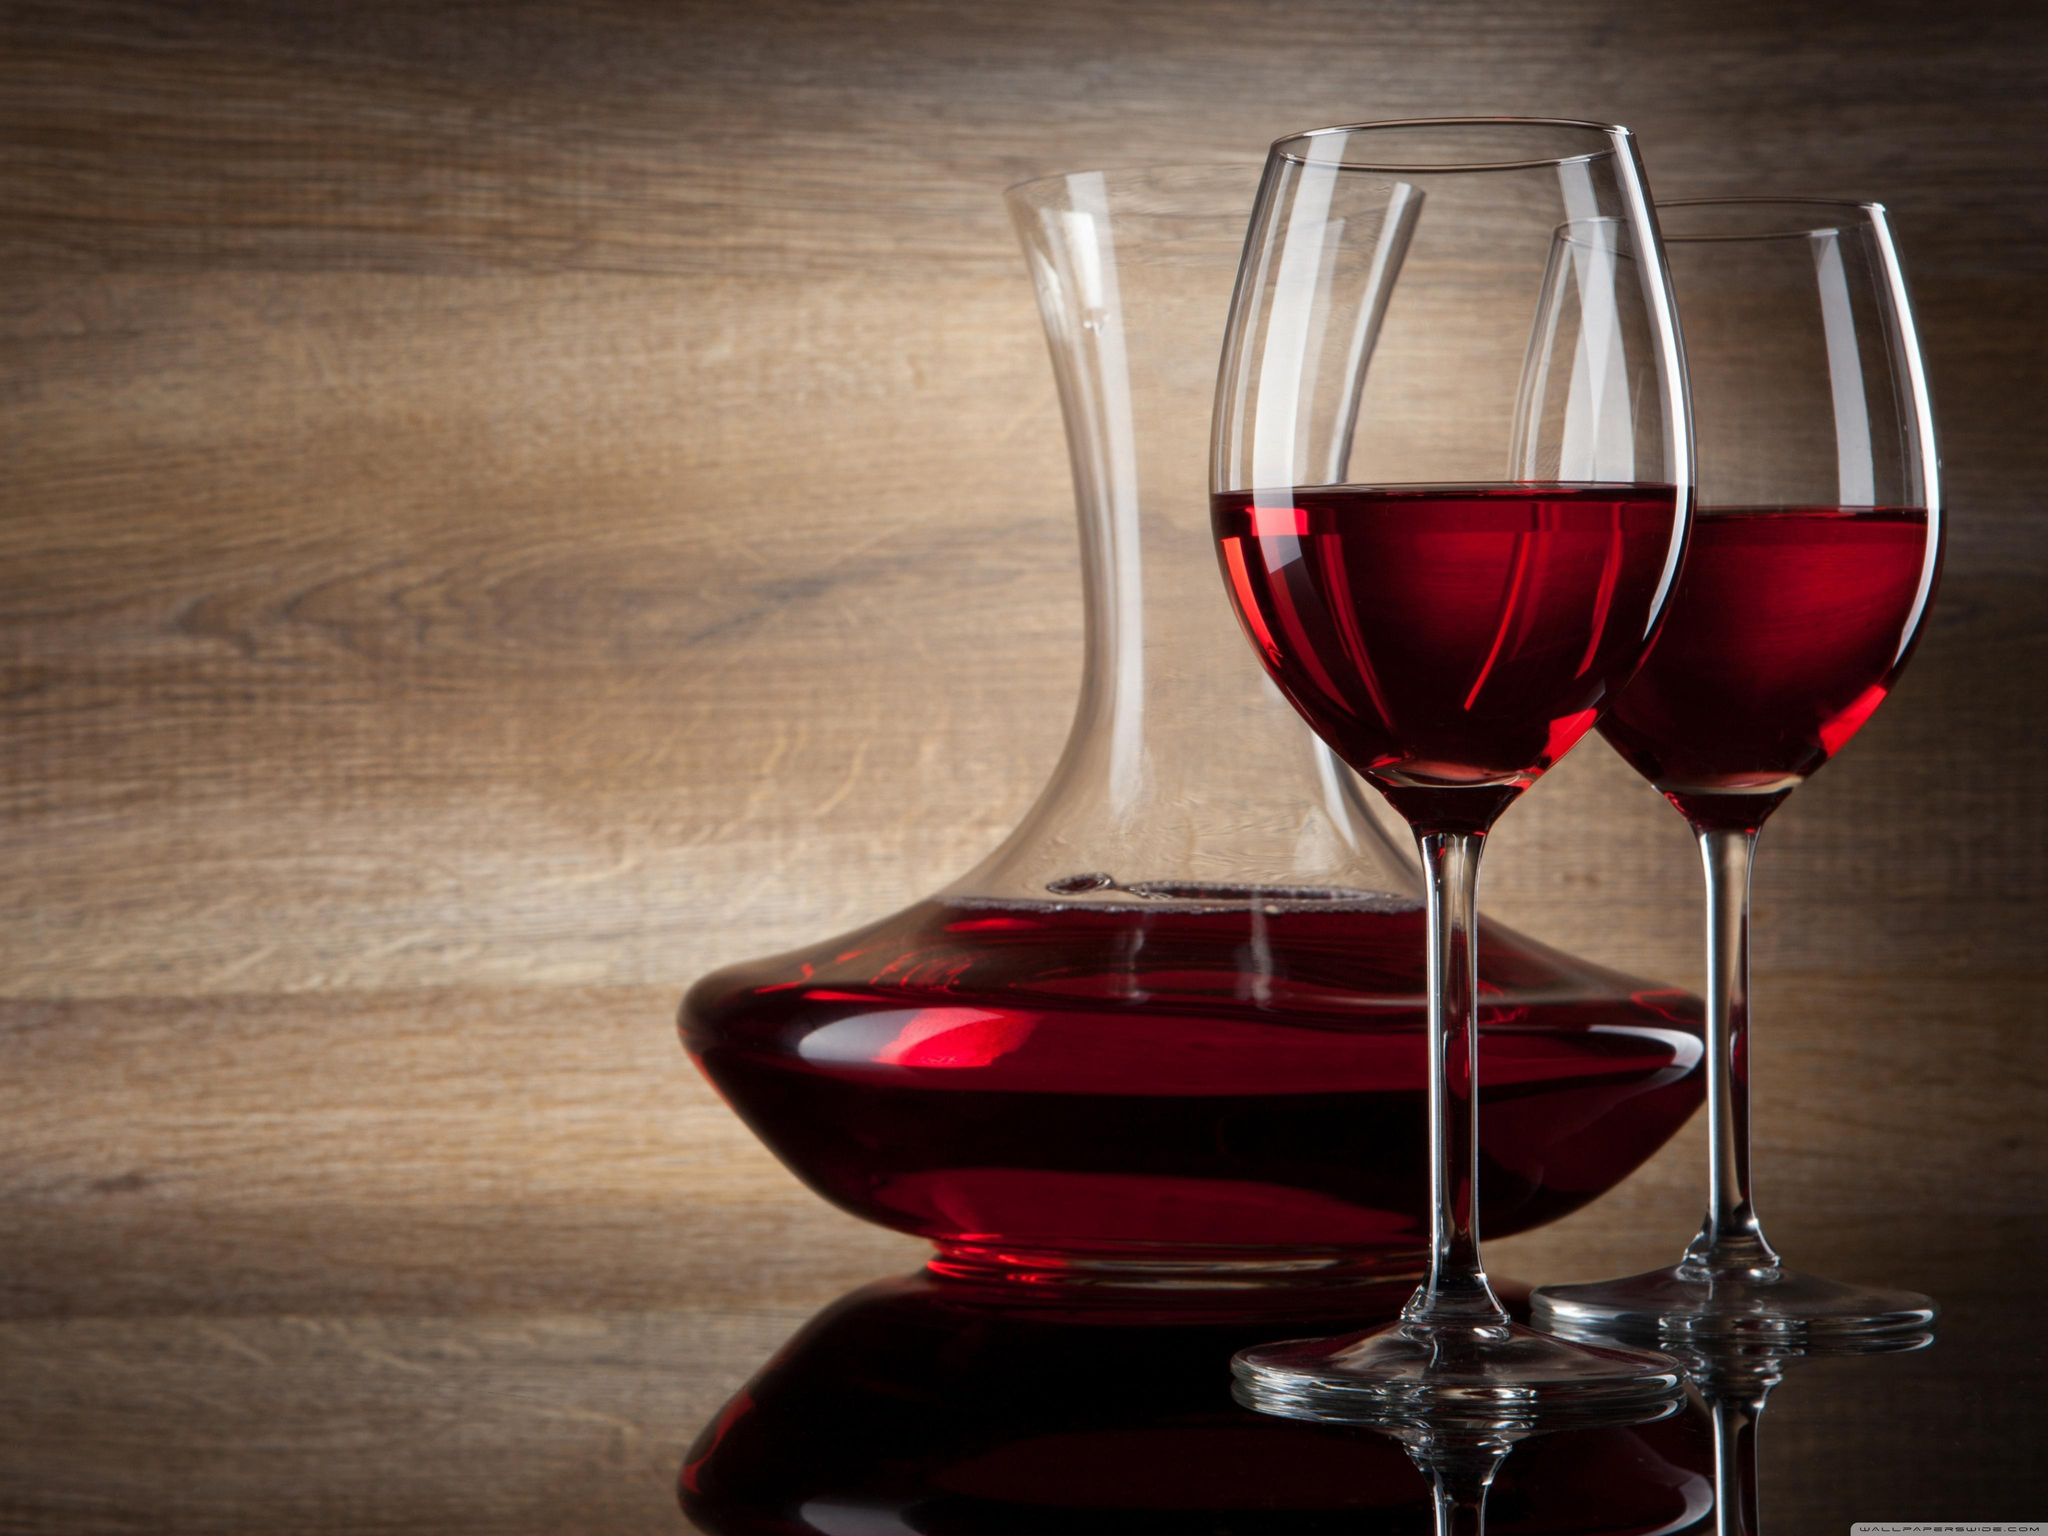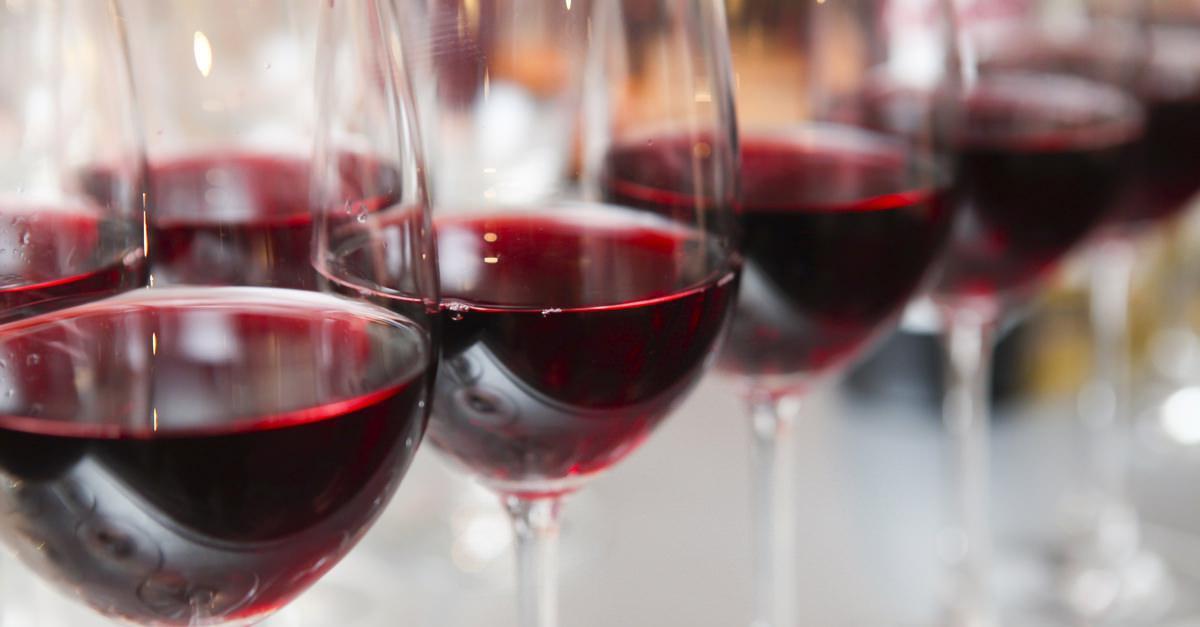The first image is the image on the left, the second image is the image on the right. Considering the images on both sides, is "The left image features exactly two wine glasses." valid? Answer yes or no. Yes. 